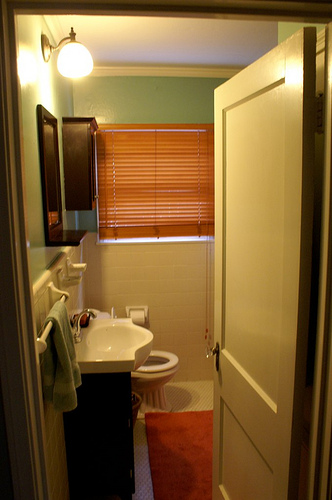Considering the layout of this bathroom, what might be a possible challenge for its users? Given the layout, one potential challenge might be the toilet's position right behind the door. If the door were to swing open suddenly while someone is using the toilet, it could result in uncomfortable or even hazardous situations. Additionally, the compact space could make it challenging for maneuvering, particularly for individuals with mobility issues. 